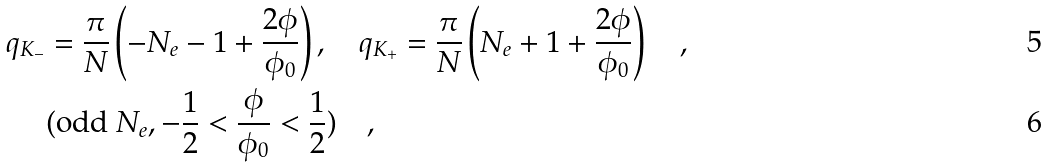Convert formula to latex. <formula><loc_0><loc_0><loc_500><loc_500>q _ { K _ { - } } & = \frac { \pi } { N } \left ( - N _ { e } - 1 + \frac { 2 \phi } { \phi _ { 0 } } \right ) , \quad q _ { K _ { + } } = \frac { \pi } { N } \left ( N _ { e } + 1 + \frac { 2 \phi } { \phi _ { 0 } } \right ) \quad , \\ & ( \text {odd } N _ { e } , - \frac { 1 } { 2 } < \frac { \phi } { \phi _ { 0 } } < \frac { 1 } { 2 } ) \quad ,</formula> 